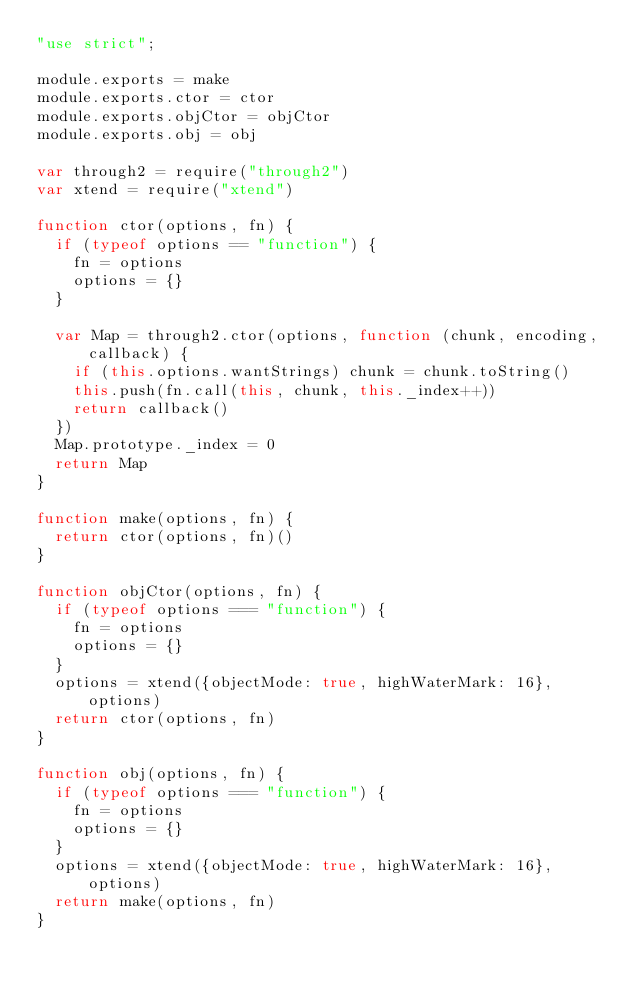<code> <loc_0><loc_0><loc_500><loc_500><_JavaScript_>"use strict";

module.exports = make
module.exports.ctor = ctor
module.exports.objCtor = objCtor
module.exports.obj = obj

var through2 = require("through2")
var xtend = require("xtend")

function ctor(options, fn) {
  if (typeof options == "function") {
    fn = options
    options = {}
  }

  var Map = through2.ctor(options, function (chunk, encoding, callback) {
    if (this.options.wantStrings) chunk = chunk.toString()
    this.push(fn.call(this, chunk, this._index++))
    return callback()
  })
  Map.prototype._index = 0
  return Map
}

function make(options, fn) {
  return ctor(options, fn)()
}

function objCtor(options, fn) {
  if (typeof options === "function") {
    fn = options
    options = {}
  }
  options = xtend({objectMode: true, highWaterMark: 16}, options)
  return ctor(options, fn)
}

function obj(options, fn) {
  if (typeof options === "function") {
    fn = options
    options = {}
  }
  options = xtend({objectMode: true, highWaterMark: 16}, options)
  return make(options, fn)
}
</code> 